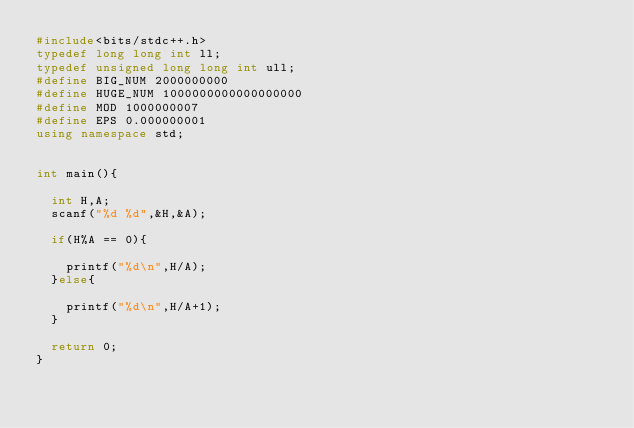Convert code to text. <code><loc_0><loc_0><loc_500><loc_500><_C++_>#include<bits/stdc++.h>
typedef long long int ll;
typedef unsigned long long int ull;
#define BIG_NUM 2000000000
#define HUGE_NUM 1000000000000000000
#define MOD 1000000007
#define EPS 0.000000001
using namespace std;


int main(){

	int H,A;
	scanf("%d %d",&H,&A);

	if(H%A == 0){

		printf("%d\n",H/A);
	}else{

		printf("%d\n",H/A+1);
	}

	return 0;
}
</code> 